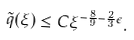Convert formula to latex. <formula><loc_0><loc_0><loc_500><loc_500>\tilde { q } ( \xi ) \leq C \xi ^ { - \frac { 8 } { 9 } - \frac { 2 } { 3 } \epsilon } .</formula> 